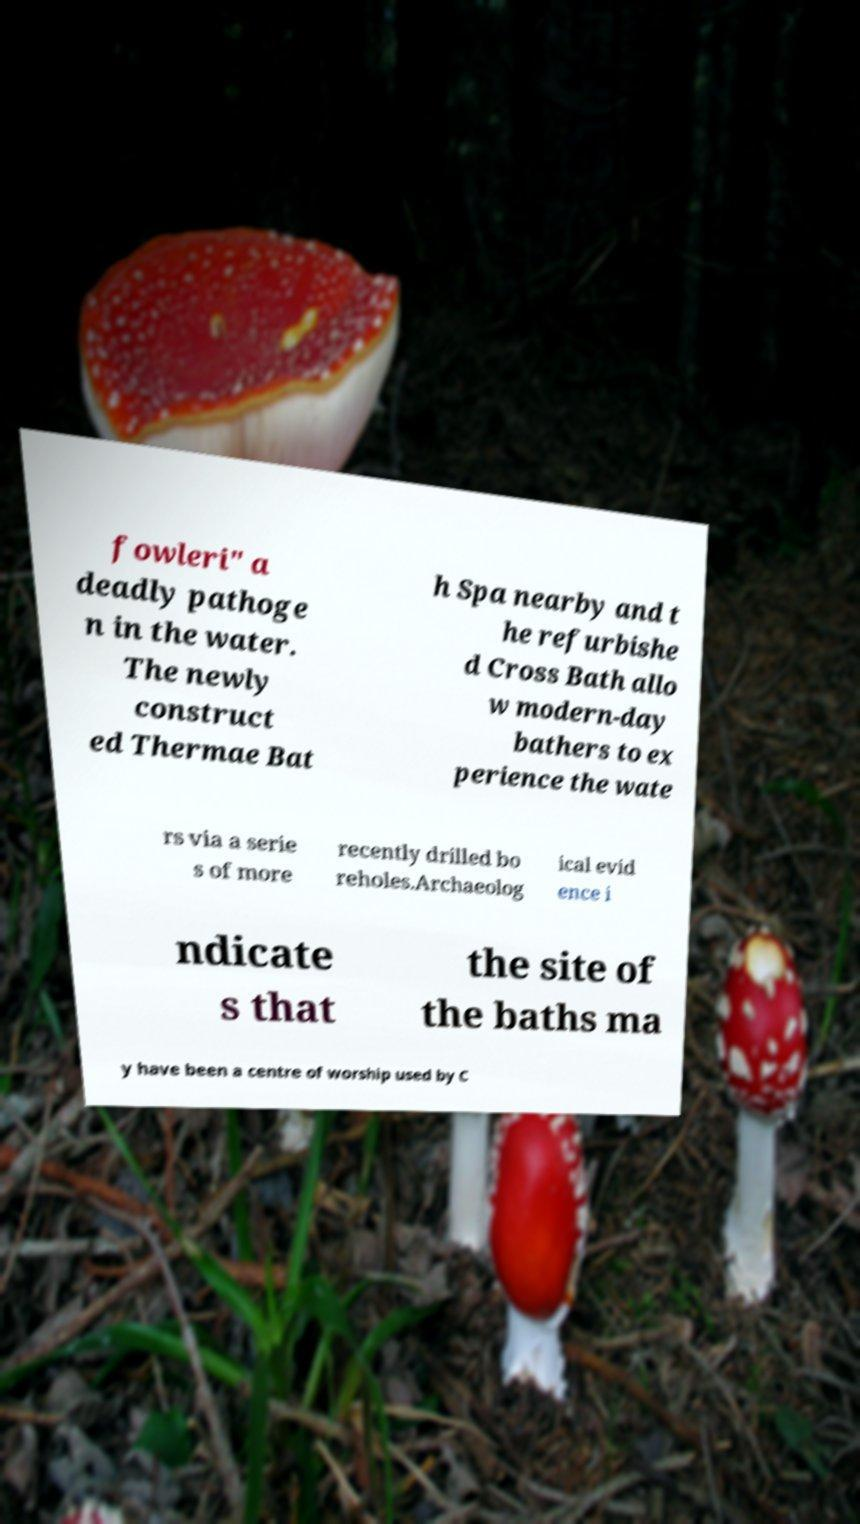Could you assist in decoding the text presented in this image and type it out clearly? fowleri" a deadly pathoge n in the water. The newly construct ed Thermae Bat h Spa nearby and t he refurbishe d Cross Bath allo w modern-day bathers to ex perience the wate rs via a serie s of more recently drilled bo reholes.Archaeolog ical evid ence i ndicate s that the site of the baths ma y have been a centre of worship used by C 